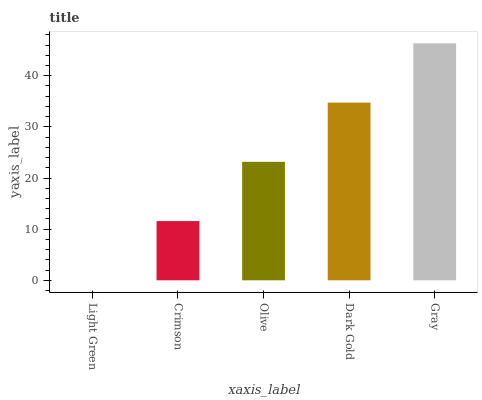Is Light Green the minimum?
Answer yes or no. Yes. Is Gray the maximum?
Answer yes or no. Yes. Is Crimson the minimum?
Answer yes or no. No. Is Crimson the maximum?
Answer yes or no. No. Is Crimson greater than Light Green?
Answer yes or no. Yes. Is Light Green less than Crimson?
Answer yes or no. Yes. Is Light Green greater than Crimson?
Answer yes or no. No. Is Crimson less than Light Green?
Answer yes or no. No. Is Olive the high median?
Answer yes or no. Yes. Is Olive the low median?
Answer yes or no. Yes. Is Light Green the high median?
Answer yes or no. No. Is Crimson the low median?
Answer yes or no. No. 